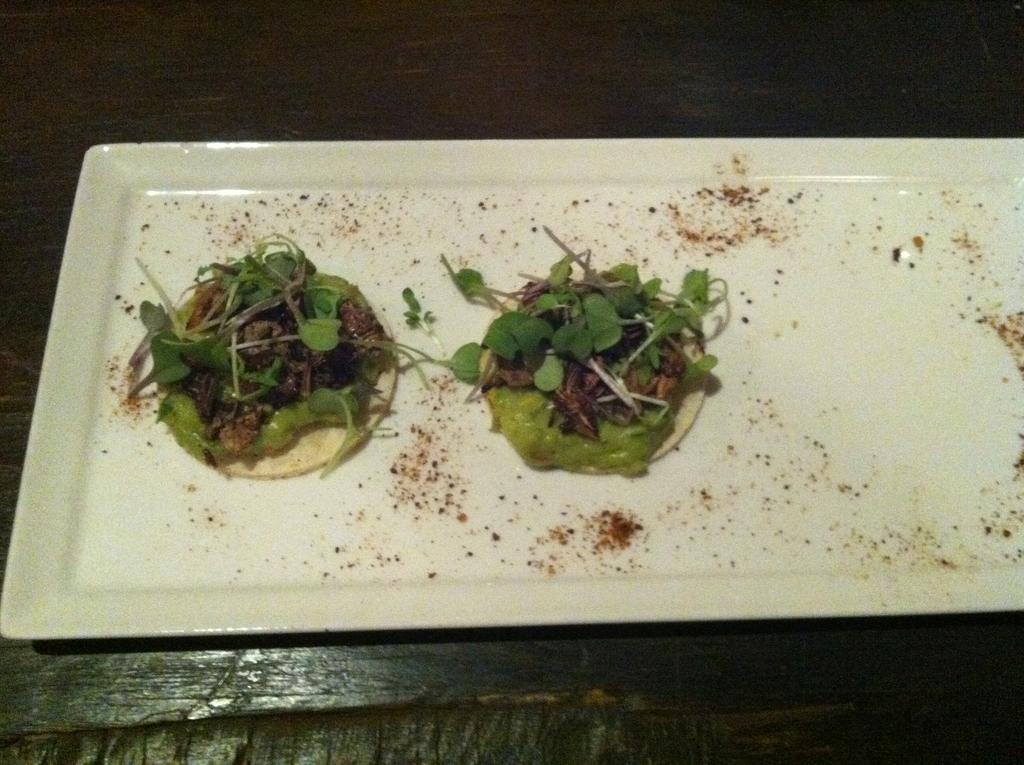What is on the plate that is visible in the image? There is food on a plate in the image. Where is the plate located in the image? The plate is in the center of the image. What type of drug is present on the plate in the image? There is no drug present on the plate in the image; it contains food. 